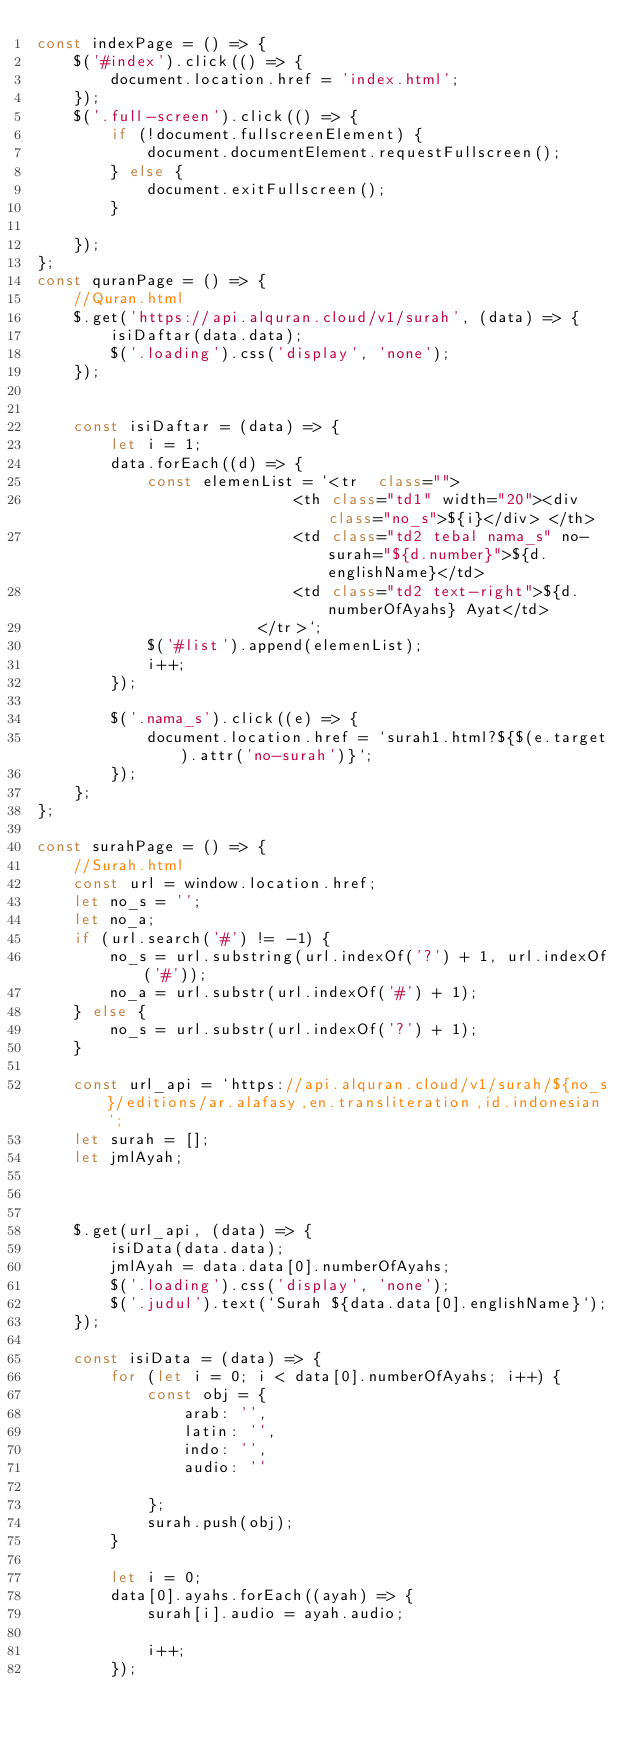Convert code to text. <code><loc_0><loc_0><loc_500><loc_500><_JavaScript_>const indexPage = () => {
    $('#index').click(() => {
        document.location.href = 'index.html';
    });
    $('.full-screen').click(() => {
        if (!document.fullscreenElement) {
            document.documentElement.requestFullscreen();
        } else {
            document.exitFullscreen();
        }

    });
};
const quranPage = () => {
    //Quran.html
    $.get('https://api.alquran.cloud/v1/surah', (data) => {
        isiDaftar(data.data);
        $('.loading').css('display', 'none');
    });


    const isiDaftar = (data) => {
        let i = 1;
        data.forEach((d) => {
            const elemenList = `<tr  class="">
                            <th class="td1" width="20"><div class="no_s">${i}</div> </th>
                            <td class="td2 tebal nama_s" no-surah="${d.number}">${d.englishName}</td>
                            <td class="td2 text-right">${d.numberOfAyahs} Ayat</td>
                        </tr>`;
            $('#list').append(elemenList);
            i++;
        });

        $('.nama_s').click((e) => {
            document.location.href = `surah1.html?${$(e.target).attr('no-surah')}`;
        });
    };
};

const surahPage = () => {
    //Surah.html
    const url = window.location.href;
    let no_s = '';
    let no_a;
    if (url.search('#') != -1) {
        no_s = url.substring(url.indexOf('?') + 1, url.indexOf('#'));
        no_a = url.substr(url.indexOf('#') + 1);
    } else {
        no_s = url.substr(url.indexOf('?') + 1);
    }

    const url_api = `https://api.alquran.cloud/v1/surah/${no_s}/editions/ar.alafasy,en.transliteration,id.indonesian`;
    let surah = [];
    let jmlAyah;



    $.get(url_api, (data) => {
        isiData(data.data);
        jmlAyah = data.data[0].numberOfAyahs;
        $('.loading').css('display', 'none');
        $('.judul').text(`Surah ${data.data[0].englishName}`);
    });

    const isiData = (data) => {
        for (let i = 0; i < data[0].numberOfAyahs; i++) {
            const obj = {
                arab: '',
                latin: '',
                indo: '',
                audio: ''

            };
            surah.push(obj);
        }

        let i = 0;
        data[0].ayahs.forEach((ayah) => {
            surah[i].audio = ayah.audio;

            i++;
        });</code> 